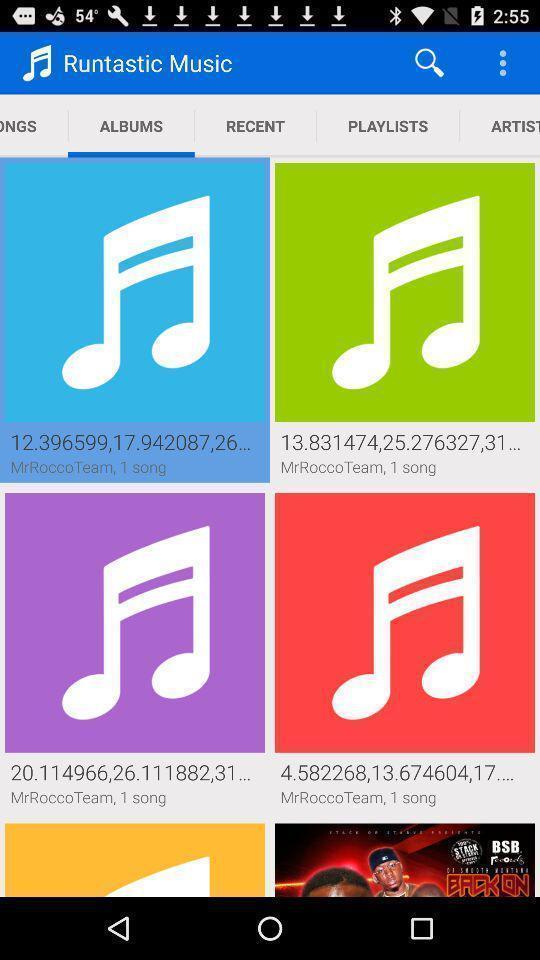Summarize the information in this screenshot. Page showing different music lists. 